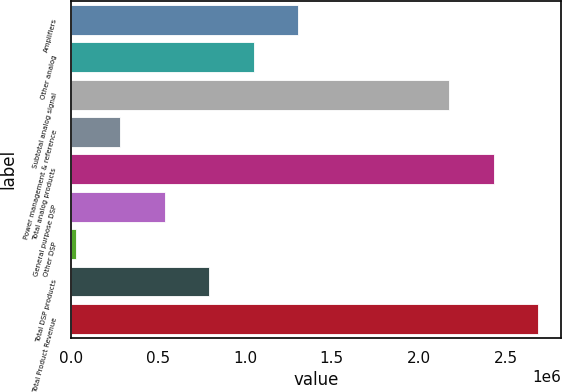Convert chart. <chart><loc_0><loc_0><loc_500><loc_500><bar_chart><fcel>Amplifiers<fcel>Other analog<fcel>Subtotal analog signal<fcel>Power management & reference<fcel>Total analog products<fcel>General purpose DSP<fcel>Other DSP<fcel>Total DSP products<fcel>Total Product Revenue<nl><fcel>1.30606e+06<fcel>1.05069e+06<fcel>2.1751e+06<fcel>284562<fcel>2.43047e+06<fcel>539937<fcel>29188<fcel>795311<fcel>2.68585e+06<nl></chart> 